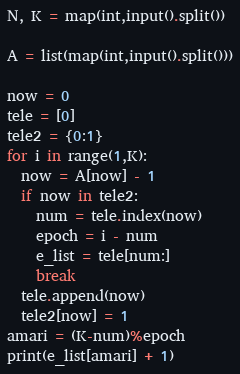Convert code to text. <code><loc_0><loc_0><loc_500><loc_500><_Python_>N, K = map(int,input().split())
 
A = list(map(int,input().split()))
 
now = 0
tele = [0]
tele2 = {0:1}
for i in range(1,K):
  now = A[now] - 1
  if now in tele2:
    num = tele.index(now)
    epoch = i - num
    e_list = tele[num:]
    break
  tele.append(now)
  tele2[now] = 1
amari = (K-num)%epoch
print(e_list[amari] + 1)
</code> 